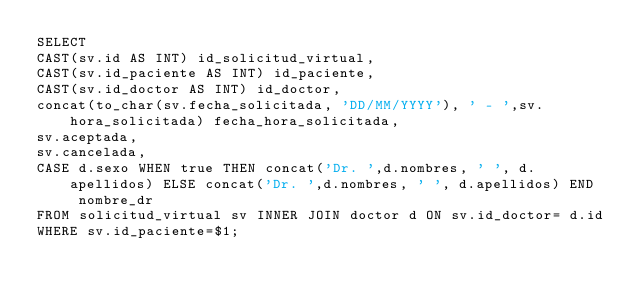<code> <loc_0><loc_0><loc_500><loc_500><_SQL_>SELECT 
CAST(sv.id AS INT) id_solicitud_virtual,
CAST(sv.id_paciente AS INT) id_paciente,
CAST(sv.id_doctor AS INT) id_doctor,
concat(to_char(sv.fecha_solicitada, 'DD/MM/YYYY'), ' - ',sv.hora_solicitada) fecha_hora_solicitada,
sv.aceptada,
sv.cancelada,
CASE d.sexo WHEN true THEN concat('Dr. ',d.nombres, ' ', d.apellidos) ELSE concat('Dr. ',d.nombres, ' ', d.apellidos) END  nombre_dr 
FROM solicitud_virtual sv INNER JOIN doctor d ON sv.id_doctor= d.id
WHERE sv.id_paciente=$1;</code> 